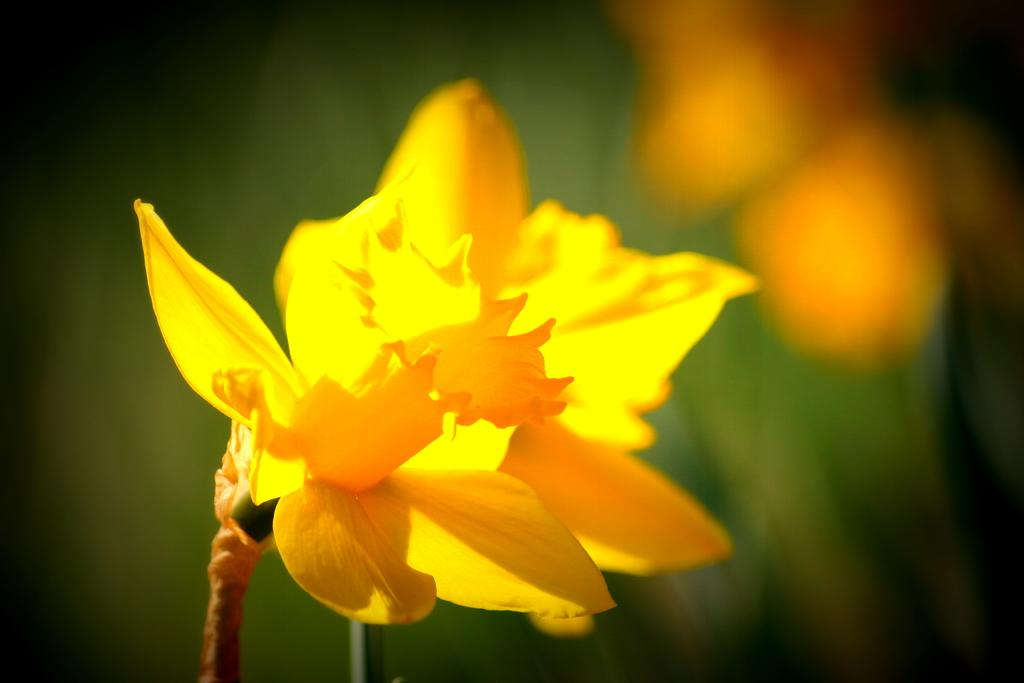What is the main subject of the image? There is a flower in the image. Can you describe the color of the flower? The flower is yellow. What colors can be seen in the background of the image? The background of the image includes green and orange colors. How many sticks are visible in the image? There are no sticks present in the image. Can you describe the self in the image? There is no self or person present in the image; it only features a yellow flower and a background with green and orange colors. 